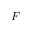<formula> <loc_0><loc_0><loc_500><loc_500>F</formula> 